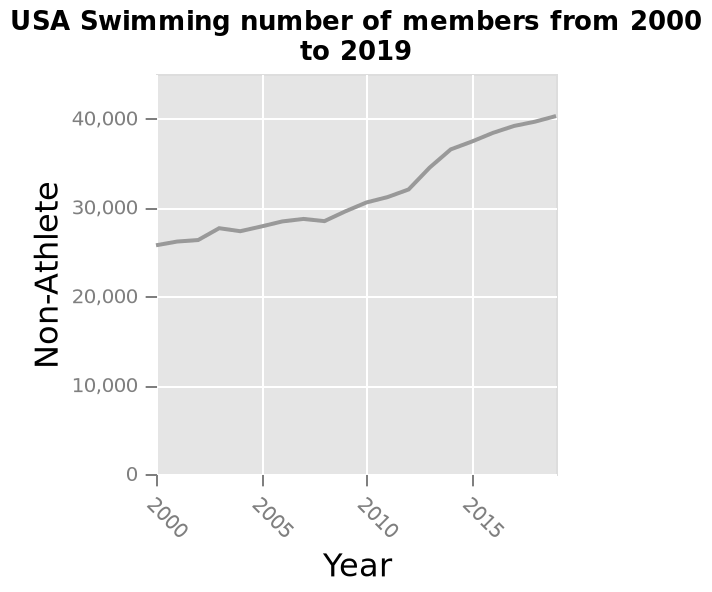<image>
What was the trend in non-athlete numbers from 2000 to 2020? The non-athlete numbers increased steadily from 2000 to 2020. What does the x-axis represent in the line diagram? The x-axis represents the Year in the line diagram. How did the non-athlete numbers change over the years? The non-athlete numbers showed a consistent increase from 2000 to 2020. What type of data is represented on the x-axis? The x-axis represents categorical data as it shows the different years. Did the non-athlete numbers decrease during the mentioned period? No, the non-athlete numbers increased steadily from 2000 to 2020. 